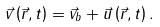Convert formula to latex. <formula><loc_0><loc_0><loc_500><loc_500>\vec { v } \left ( \vec { r } , t \right ) = \vec { v } _ { b } + \vec { u } \left ( \vec { r } , t \right ) .</formula> 